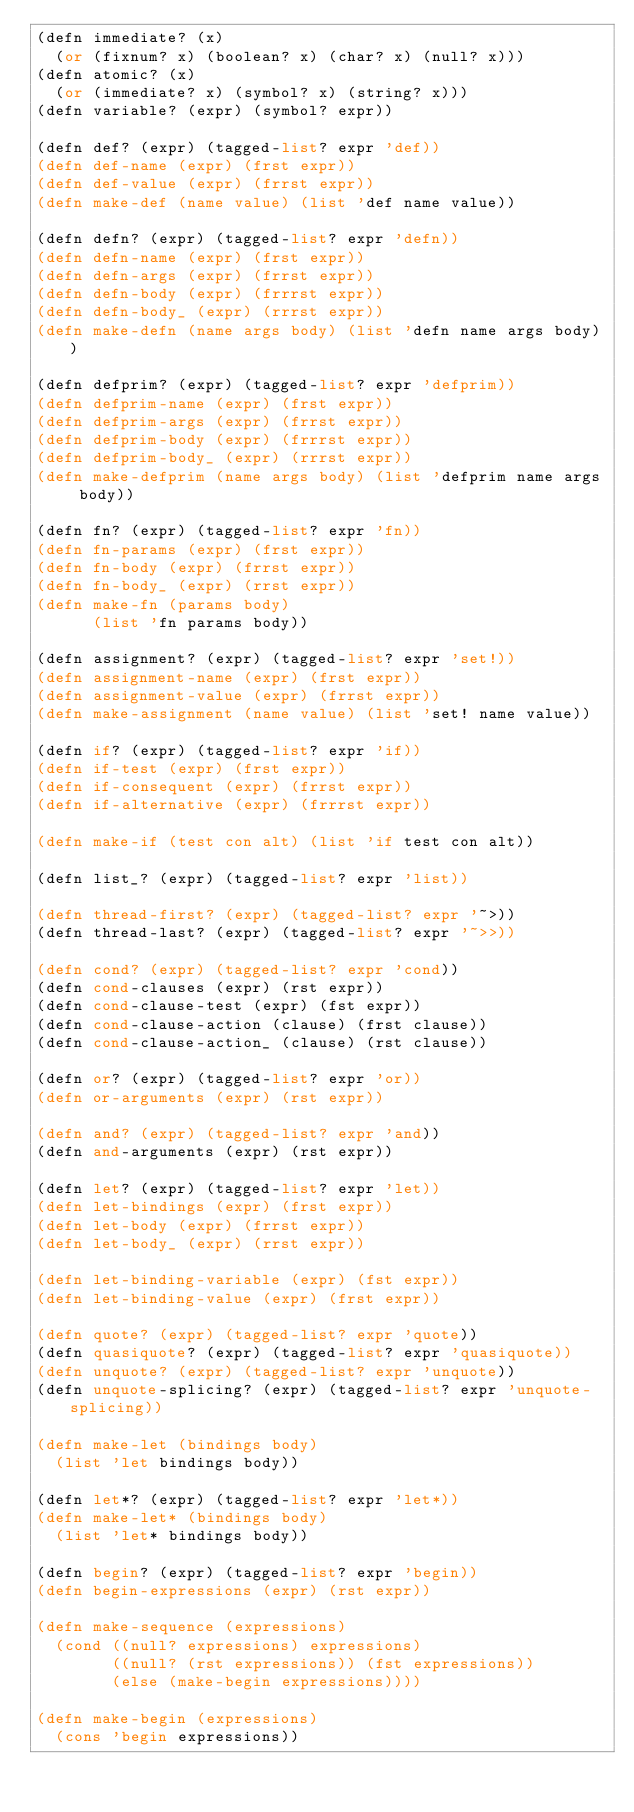Convert code to text. <code><loc_0><loc_0><loc_500><loc_500><_Scheme_>(defn immediate? (x)
  (or (fixnum? x) (boolean? x) (char? x) (null? x)))
(defn atomic? (x)
  (or (immediate? x) (symbol? x) (string? x))) 
(defn variable? (expr) (symbol? expr))

(defn def? (expr) (tagged-list? expr 'def))
(defn def-name (expr) (frst expr))
(defn def-value (expr) (frrst expr))
(defn make-def (name value) (list 'def name value))

(defn defn? (expr) (tagged-list? expr 'defn))
(defn defn-name (expr) (frst expr))
(defn defn-args (expr) (frrst expr))
(defn defn-body (expr) (frrrst expr))
(defn defn-body_ (expr) (rrrst expr))
(defn make-defn (name args body) (list 'defn name args body))

(defn defprim? (expr) (tagged-list? expr 'defprim))
(defn defprim-name (expr) (frst expr))
(defn defprim-args (expr) (frrst expr))
(defn defprim-body (expr) (frrrst expr))
(defn defprim-body_ (expr) (rrrst expr))
(defn make-defprim (name args body) (list 'defprim name args body))

(defn fn? (expr) (tagged-list? expr 'fn))
(defn fn-params (expr) (frst expr))
(defn fn-body (expr) (frrst expr))
(defn fn-body_ (expr) (rrst expr))
(defn make-fn (params body)
      (list 'fn params body))

(defn assignment? (expr) (tagged-list? expr 'set!))
(defn assignment-name (expr) (frst expr))
(defn assignment-value (expr) (frrst expr))
(defn make-assignment (name value) (list 'set! name value))

(defn if? (expr) (tagged-list? expr 'if))
(defn if-test (expr) (frst expr))
(defn if-consequent (expr) (frrst expr))
(defn if-alternative (expr) (frrrst expr))

(defn make-if (test con alt) (list 'if test con alt))

(defn list_? (expr) (tagged-list? expr 'list))

(defn thread-first? (expr) (tagged-list? expr '~>))
(defn thread-last? (expr) (tagged-list? expr '~>>))

(defn cond? (expr) (tagged-list? expr 'cond))
(defn cond-clauses (expr) (rst expr))
(defn cond-clause-test (expr) (fst expr))
(defn cond-clause-action (clause) (frst clause))
(defn cond-clause-action_ (clause) (rst clause))

(defn or? (expr) (tagged-list? expr 'or))
(defn or-arguments (expr) (rst expr))

(defn and? (expr) (tagged-list? expr 'and))
(defn and-arguments (expr) (rst expr))

(defn let? (expr) (tagged-list? expr 'let))
(defn let-bindings (expr) (frst expr))
(defn let-body (expr) (frrst expr))
(defn let-body_ (expr) (rrst expr))

(defn let-binding-variable (expr) (fst expr))
(defn let-binding-value (expr) (frst expr))

(defn quote? (expr) (tagged-list? expr 'quote))
(defn quasiquote? (expr) (tagged-list? expr 'quasiquote))
(defn unquote? (expr) (tagged-list? expr 'unquote))
(defn unquote-splicing? (expr) (tagged-list? expr 'unquote-splicing))

(defn make-let (bindings body)
  (list 'let bindings body))

(defn let*? (expr) (tagged-list? expr 'let*))
(defn make-let* (bindings body)
  (list 'let* bindings body))

(defn begin? (expr) (tagged-list? expr 'begin))
(defn begin-expressions (expr) (rst expr))

(defn make-sequence (expressions)
  (cond ((null? expressions) expressions)
        ((null? (rst expressions)) (fst expressions))
        (else (make-begin expressions))))

(defn make-begin (expressions)
  (cons 'begin expressions))
</code> 